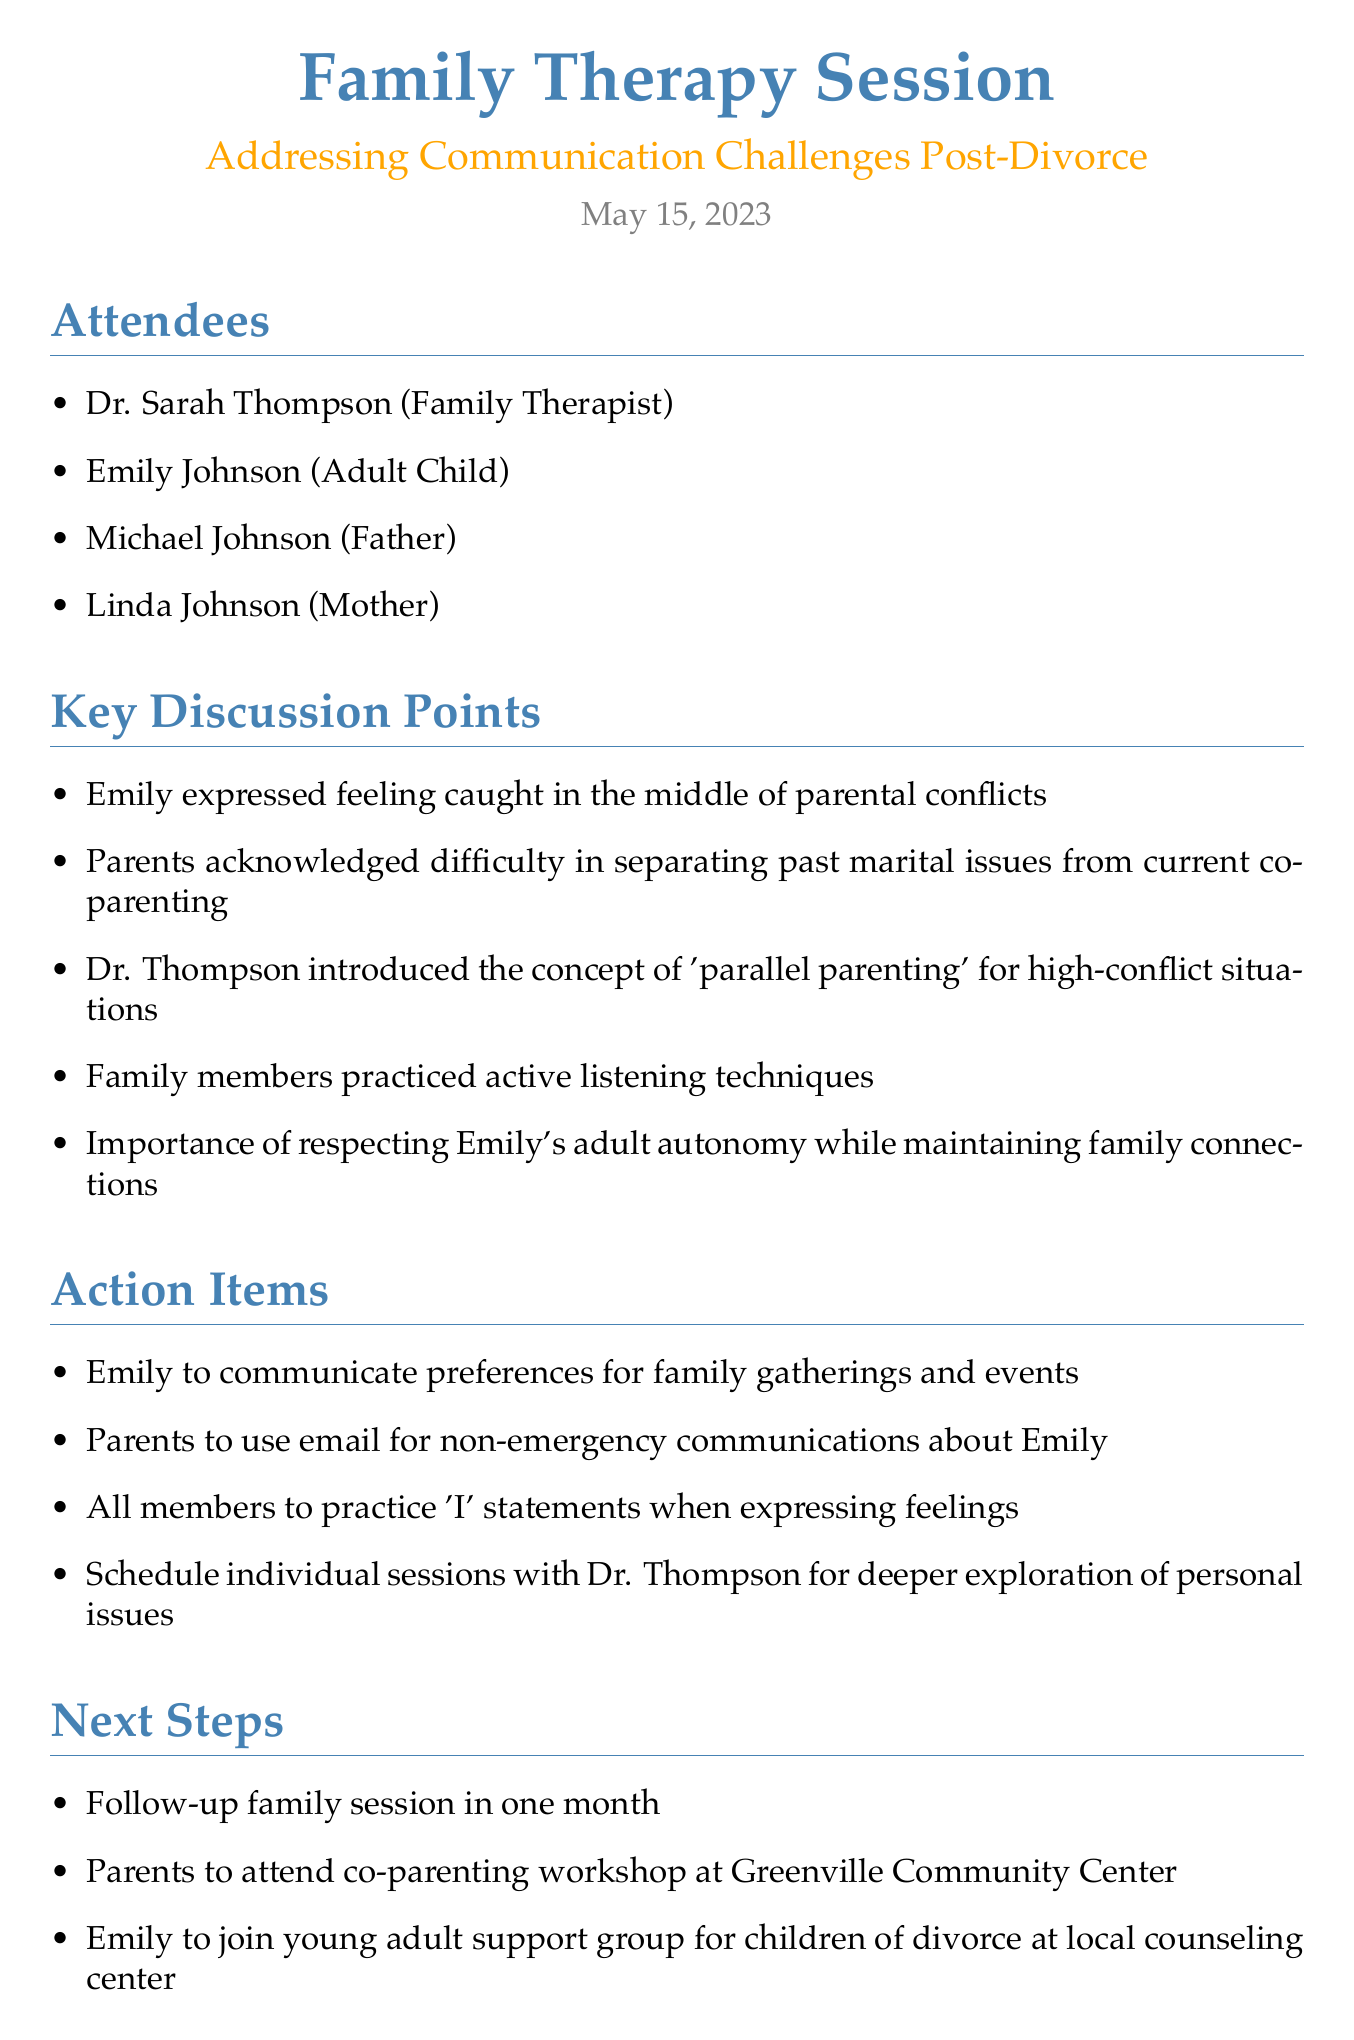What is the title of the meeting? The title of the meeting is presented at the top of the document, clearly stating its purpose.
Answer: Family Therapy Session: Addressing Communication Challenges Post-Divorce Who attended the meeting? The attendees section lists the individuals present at the meeting.
Answer: Dr. Sarah Thompson, Emily Johnson, Michael Johnson, Linda Johnson What was one of the key discussion points? This question refers to the main discussions that took place during the meeting, as outlined in the document.
Answer: Emily expressed feeling caught in the middle of parental conflicts What is one action item for Emily? The action items specify tasks assigned to individuals based on the discussions in the meeting.
Answer: Emily to communicate preferences for family gatherings and events When is the follow-up family session scheduled? The next steps section provides information about future meetings or actions to be taken after the session.
Answer: in one month What type of workshop will the parents attend? The document mentions specific workshops or resources for the parents to support their co-parenting efforts.
Answer: co-parenting workshop What is one of the recommended resources? The resources section includes suggestions for further reading or tools to help the family.
Answer: The Co-Parenting Handbook by Karen Bonnell What communication method should the parents use? The action items specify the means of communication to minimize conflict.
Answer: email for non-emergency communications about Emily 